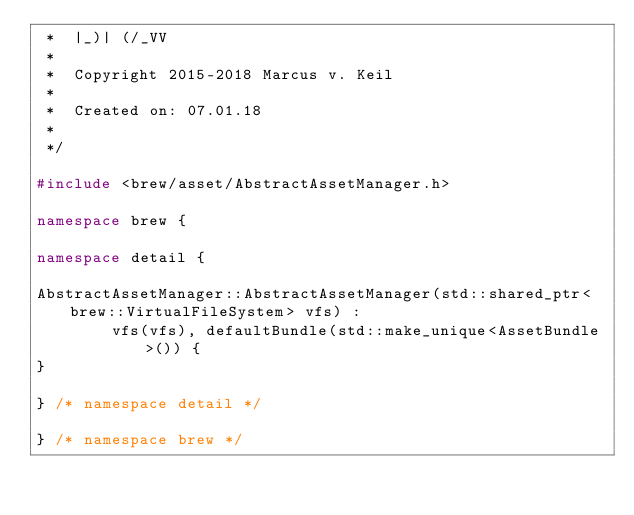Convert code to text. <code><loc_0><loc_0><loc_500><loc_500><_C++_> *  |_)| (/_VV
 *
 *  Copyright 2015-2018 Marcus v. Keil
 *
 *  Created on: 07.01.18
 *
 */

#include <brew/asset/AbstractAssetManager.h>

namespace brew {

namespace detail {

AbstractAssetManager::AbstractAssetManager(std::shared_ptr<brew::VirtualFileSystem> vfs) :
        vfs(vfs), defaultBundle(std::make_unique<AssetBundle>()) {
}

} /* namespace detail */

} /* namespace brew */
</code> 